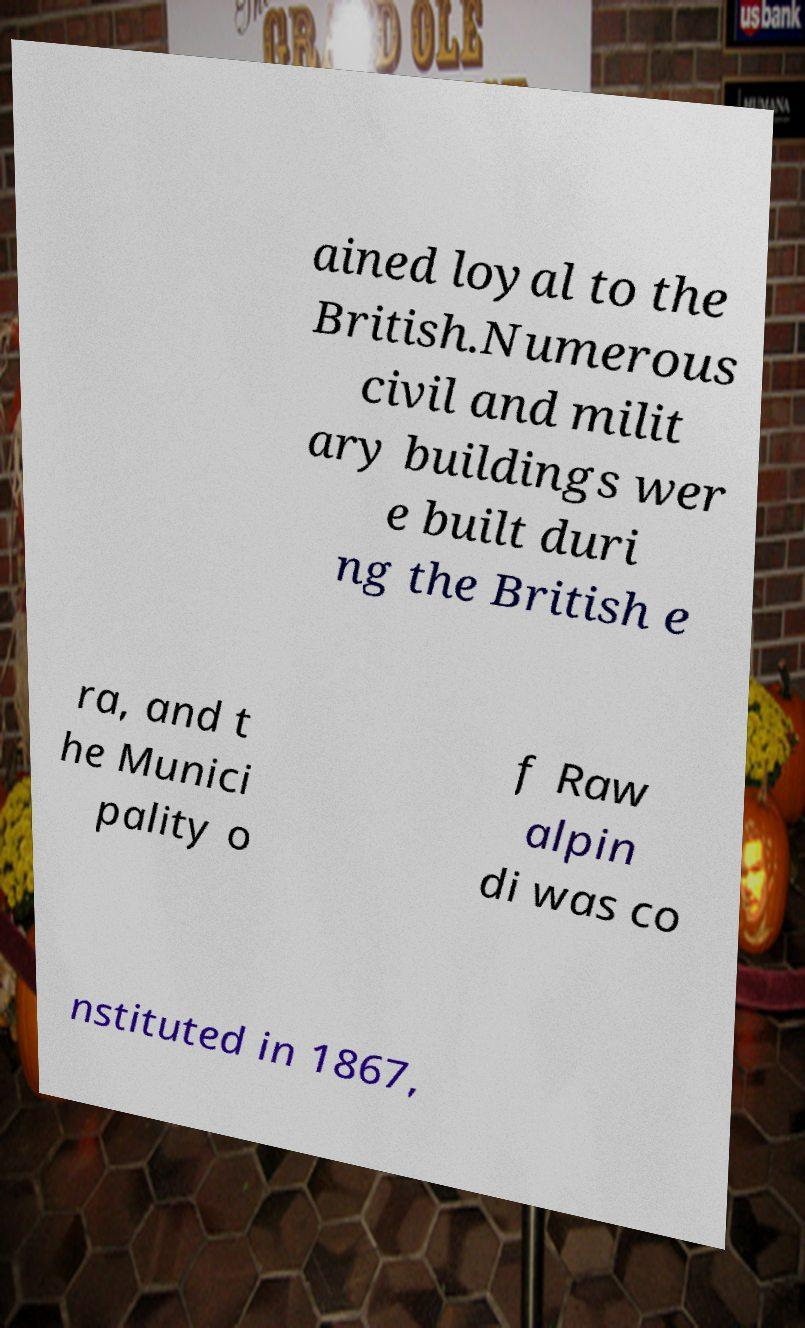What messages or text are displayed in this image? I need them in a readable, typed format. ained loyal to the British.Numerous civil and milit ary buildings wer e built duri ng the British e ra, and t he Munici pality o f Raw alpin di was co nstituted in 1867, 